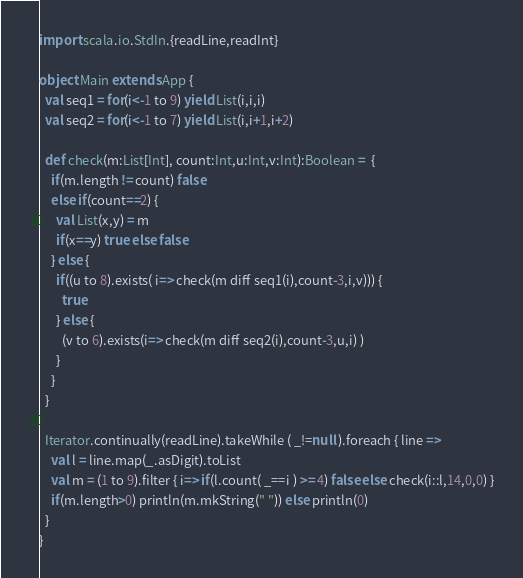<code> <loc_0><loc_0><loc_500><loc_500><_Scala_>import scala.io.StdIn.{readLine,readInt}

object Main extends App {
  val seq1 = for(i<-1 to 9) yield List(i,i,i)
  val seq2 = for(i<-1 to 7) yield List(i,i+1,i+2)

  def check(m:List[Int], count:Int,u:Int,v:Int):Boolean =  {
    if(m.length != count) false
    else if(count==2) {
      val List(x,y) = m
      if(x==y) true else false
    } else {
      if((u to 8).exists( i=> check(m diff seq1(i),count-3,i,v))) {
        true
      } else {
        (v to 6).exists(i=> check(m diff seq2(i),count-3,u,i) )
      }
    }
  }

  Iterator.continually(readLine).takeWhile ( _!=null ).foreach { line =>
    val l = line.map(_.asDigit).toList
    val m = (1 to 9).filter { i=> if(l.count( _==i ) >= 4) false else check(i::l,14,0,0) }
    if(m.length>0) println(m.mkString(" ")) else println(0)
  }
}</code> 